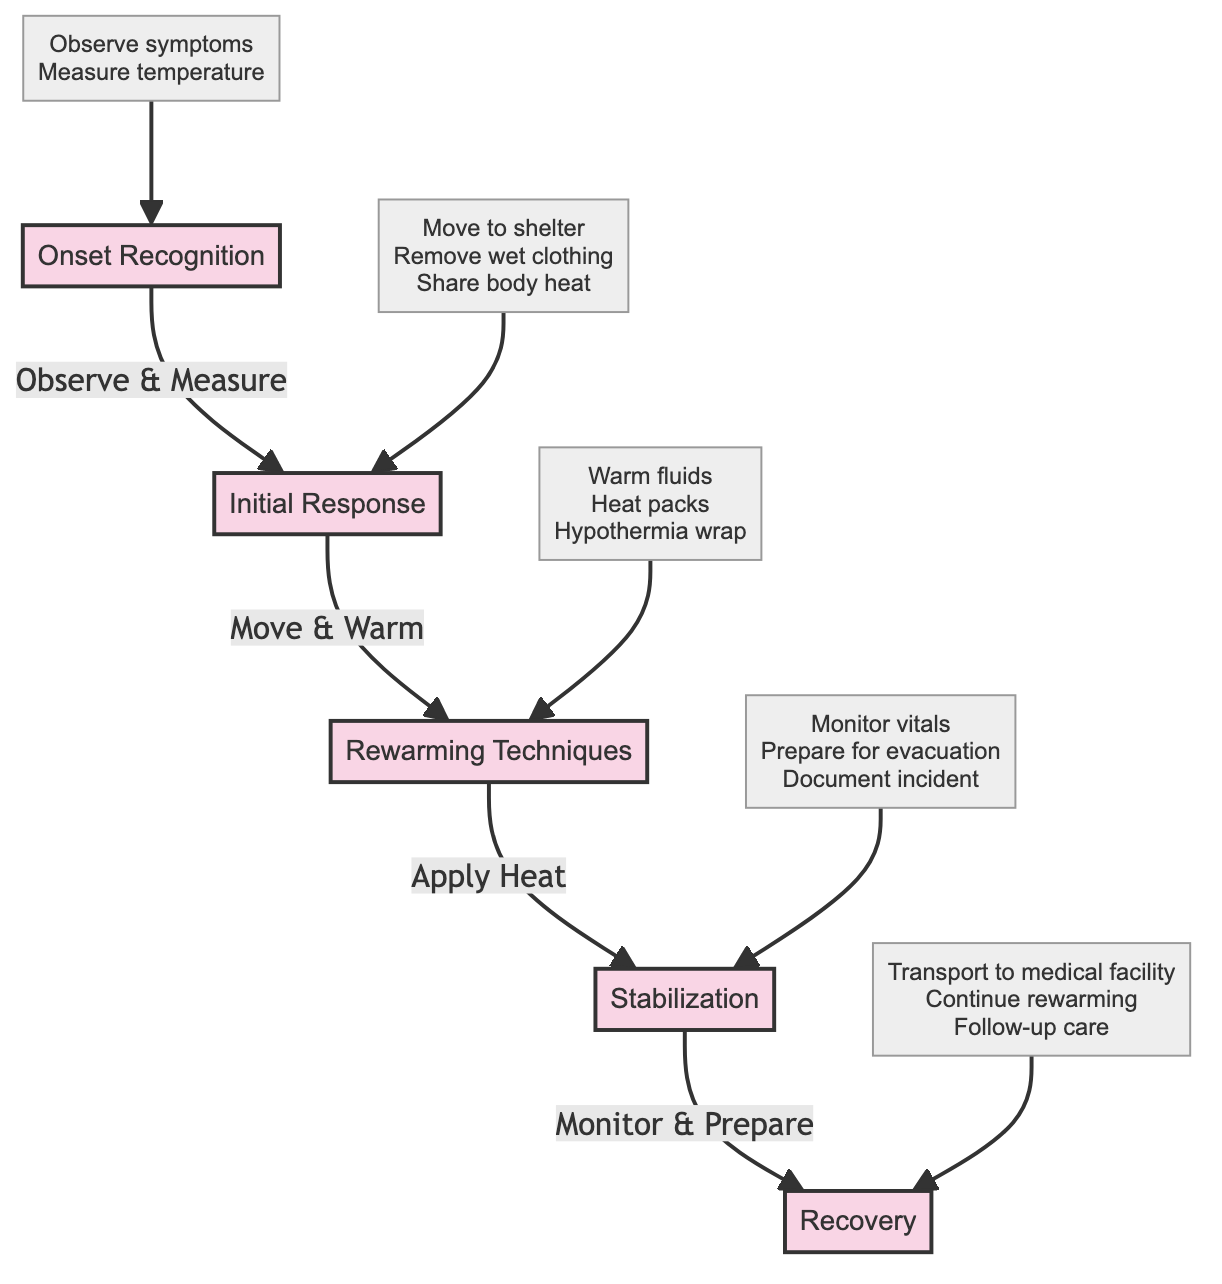What are the initial symptoms to observe in Onset Recognition? The diagram indicates that in the Onset Recognition phase, initial symptoms to observe include shivering, slurred speech, and coordination problems. These are explicitly listed under the actions of that phase.
Answer: Shivering, slurred speech, coordination problems What action follows Moving to Shelter? According to the flow of the diagram, moving to shelter leads to the next action of removing wet clothing, which is noted under the Initial Response phase.
Answer: Remove wet clothing How many main phases are in the clinical pathway? By counting the distinct phases listed in the diagram—Onset Recognition, Initial Response, Rewarming Techniques, Stabilization, and Recovery—we find there are five main phases in total.
Answer: Five What is the primary purpose of the Rewarming Techniques phase? The Rewarming Techniques phase primarily includes actions to apply heat and provide warmth to the individual experiencing hypothermia. This can be inferred from the listed actions that focus on warming strategies.
Answer: Apply heat What should be done during the Stabilization phase regarding vital signs? During the Stabilization phase, the diagram specifies the action to monitor vital signs, emphasizing the need to regularly check pulse, breathing, and consciousness.
Answer: Monitor vital signs What is the last action listed in the Recovery phase? According to the diagram, the last action in the Recovery phase is to ensure the victim receives medical evaluation and follow-up care, clearly stated as part of the recovery process.
Answer: Follow-up care What relationship exists between Applying Heat and Monitoring Vital Signs? The diagram shows a sequential relationship where after applying heat in the Rewarming Techniques phase, the next step is to monitor vital signs in the Stabilization phase, indicating that applying heat leads to stabilization efforts.
Answer: Sequential relationship What type of evacuation should be prepared for during Stabilization? The diagram indicates that during the Stabilization phase, you should prepare for long-term care, which includes using a satellite phone for emergency evacuation if necessary, highlighting the importance of being ready for evacuation.
Answer: Emergency evacuation Which phase involves administering warm fluids? The actions listed under the Rewarming Techniques phase include administering warm fluids. This phase is focused on strategies to warm the individual effectively.
Answer: Rewarming Techniques 